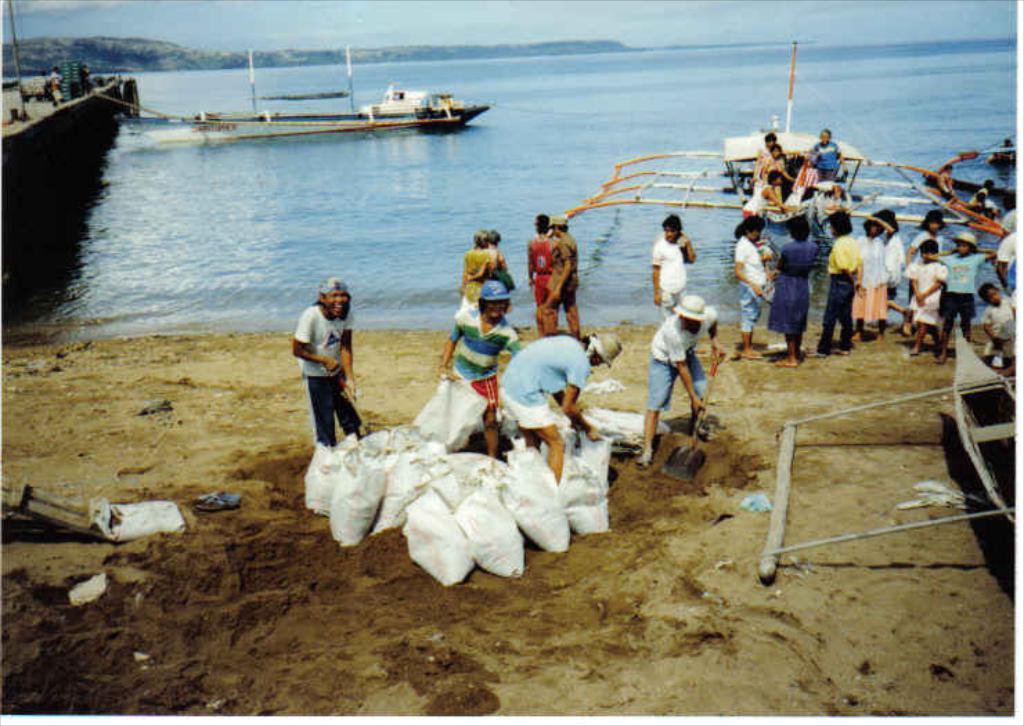Please provide a concise description of this image. In this image, there are a few people. We can see the ground with some objects. We can also see some bags. We can see some water with a boat sailing on it. We can also see a boat on the left. We can see a path above the water. We can see a pole and some objects on the top of the water. We can see some hills and the sky. 